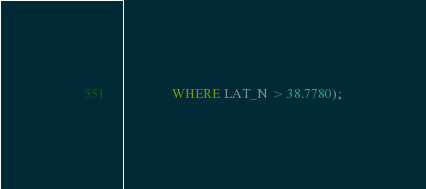<code> <loc_0><loc_0><loc_500><loc_500><_SQL_>               WHERE LAT_N > 38.7780);</code> 